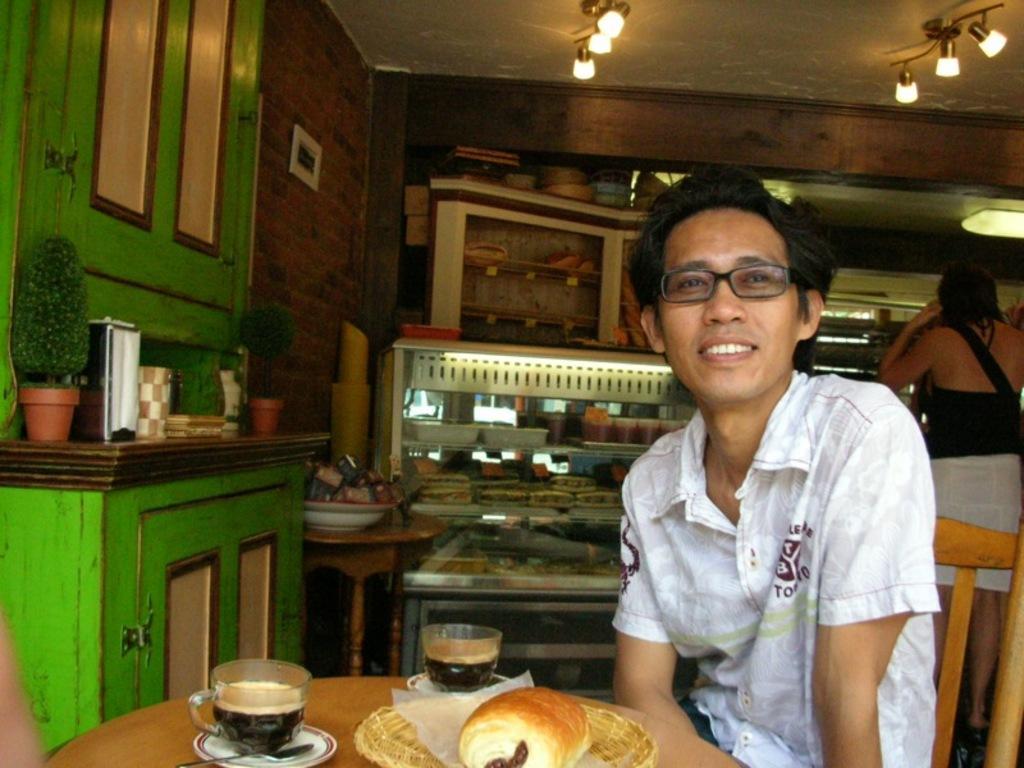How would you summarize this image in a sentence or two? There is a table on that there is food item and a cups of tea and a man sititing on the chair and in the background there is a women standing and there is desk on that some containers are kept. 